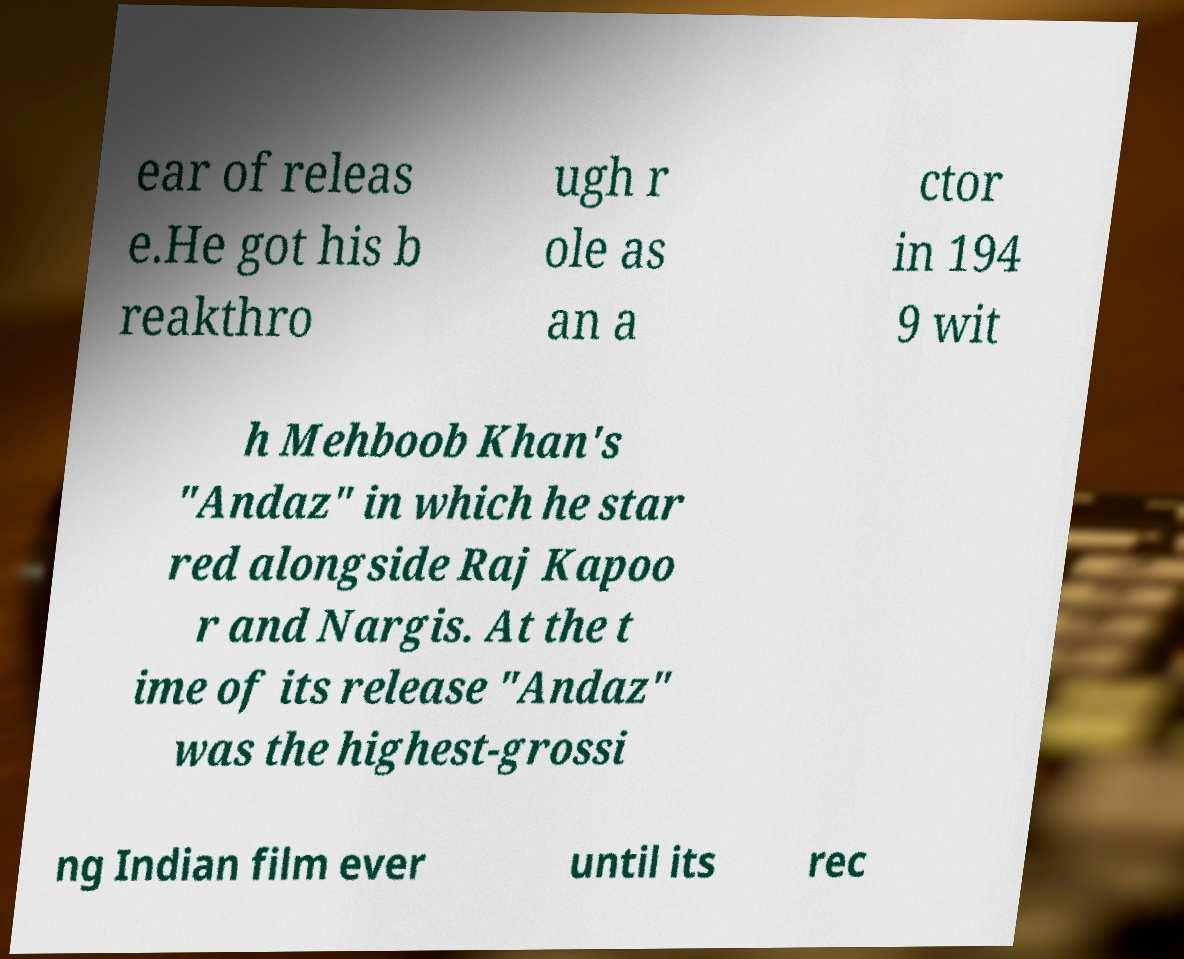Can you read and provide the text displayed in the image?This photo seems to have some interesting text. Can you extract and type it out for me? ear of releas e.He got his b reakthro ugh r ole as an a ctor in 194 9 wit h Mehboob Khan's "Andaz" in which he star red alongside Raj Kapoo r and Nargis. At the t ime of its release "Andaz" was the highest-grossi ng Indian film ever until its rec 